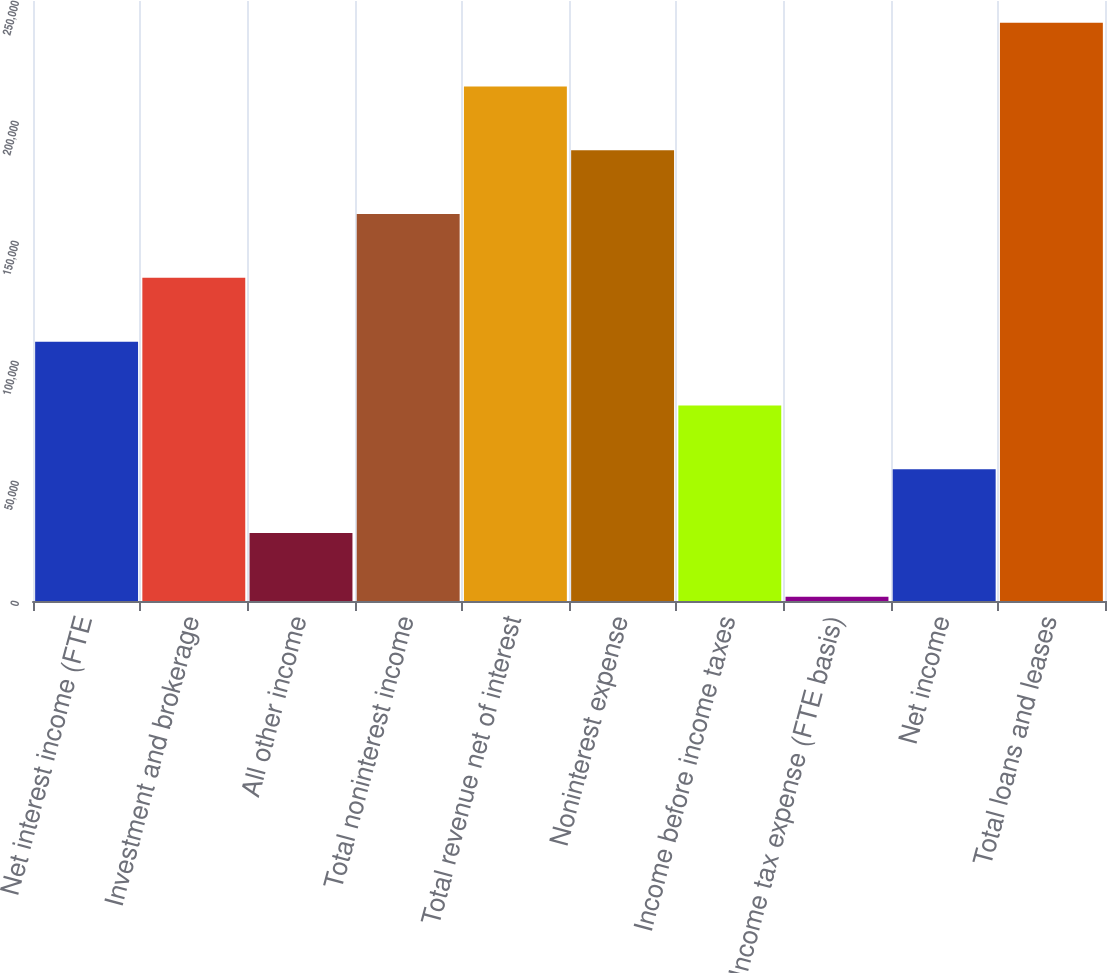<chart> <loc_0><loc_0><loc_500><loc_500><bar_chart><fcel>Net interest income (FTE<fcel>Investment and brokerage<fcel>All other income<fcel>Total noninterest income<fcel>Total revenue net of interest<fcel>Noninterest expense<fcel>Income before income taxes<fcel>Income tax expense (FTE basis)<fcel>Net income<fcel>Total loans and leases<nl><fcel>108065<fcel>134639<fcel>28341.4<fcel>161213<fcel>214362<fcel>187788<fcel>81490.2<fcel>1767<fcel>54915.8<fcel>240937<nl></chart> 